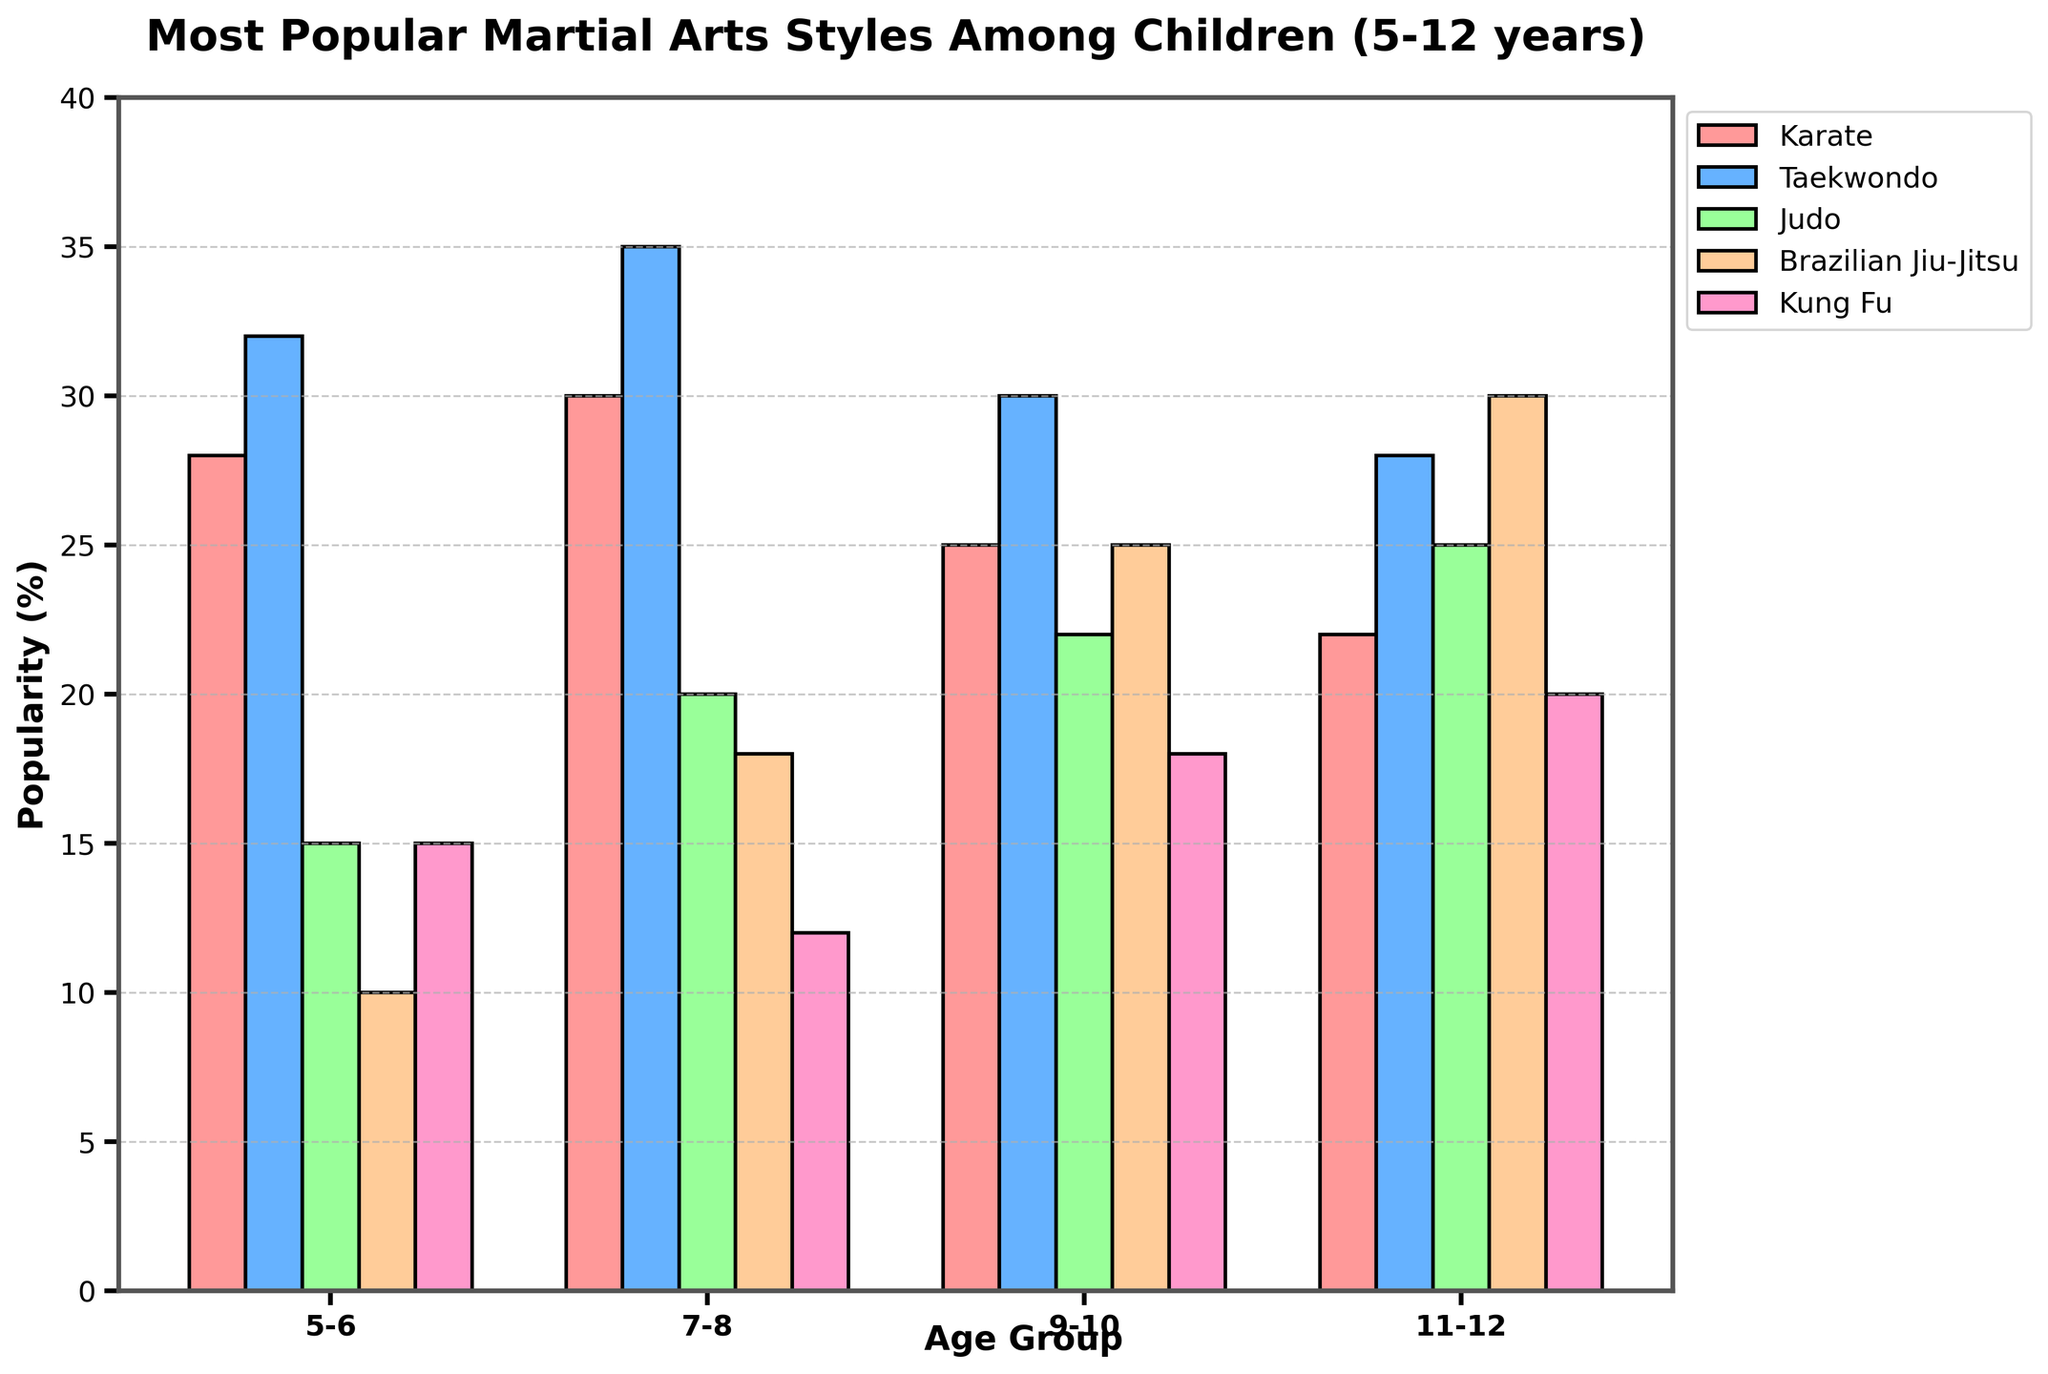What's the most popular martial arts style for age group 5-6? Observe the height of the bars for the age group 5-6 and identify the highest one. The highest bar corresponds to Taekwondo.
Answer: Taekwondo By how much does the popularity of Brazilian Jiu-Jitsu increase from age group 5-6 to 11-12? Look at the values for Brazilian Jiu-Jitsu at age groups 5-6 (10) and 11-12 (30). Subtract the smaller value from the larger one: 30 - 10.
Answer: 20 Which martial art shows the most consistent popularity across all age groups? Compare the variances in the heights of the bars for each martial art. Note that the bars for Taekwondo show relatively less variation compared to other martial arts.
Answer: Taekwondo For the age group 7-8, which martial arts are less popular than Taekwondo and by how much? Compare the height of the Taekwondo bar (35) with the other martial arts in the same age group: Karate (30), Judo (20), Brazilian Jiu-Jitsu (18), and Kung Fu (12). Calculate the differences: 35 - 30, 35 - 20, 35 - 18, and 35 - 12.
Answer: Karate by 5, Judo by 15, Brazilian Jiu-Jitsu by 17, Kung Fu by 23 Which martial art has the largest increase in popularity from age group 5-6 to 11-12? Find the difference between the values for each martial art from age group 5-6 to 11-12. The increments are: Karate (22-28 = -6), Taekwondo (28-32 = -4), Judo (25-15 = 10), Brazilian Jiu-Jitsu (30-10 = 20), Kung Fu (20-15 = 5). The largest increment is for Brazilian Jiu-Jitsu (20).
Answer: Brazilian Jiu-Jitsu What is the total popularity percentage for Kung Fu across all age groups? Sum the popularity percentages for Kung Fu across all age groups: 15 + 12 + 18 + 20.
Answer: 65 Compare the popularity of Karate and Judo for the age group 11-12. Which one is more popular and by how much? Look at the bars for Karate (22) and Judo (25) for the age group 11-12 and find the difference: 25 - 22.
Answer: Judo by 3 What is the average popularity of Taekwondo across all age groups? Sum the popularity percentages for Taekwondo across all age groups: 32 + 35 + 30 + 28. Divide by the number of age groups (4): (32 + 35 + 30 + 28)/4.
Answer: 31.25 For the age group 9-10, how much more popular is Brazilian Jiu-Jitsu compared to Kung Fu? Look at the bars for Brazilian Jiu-Jitsu (25) and Kung Fu (18) for the age group 9-10. Subtract the value for Kung Fu from Brazilian Jiu-Jitsu: 25 - 18.
Answer: 7 